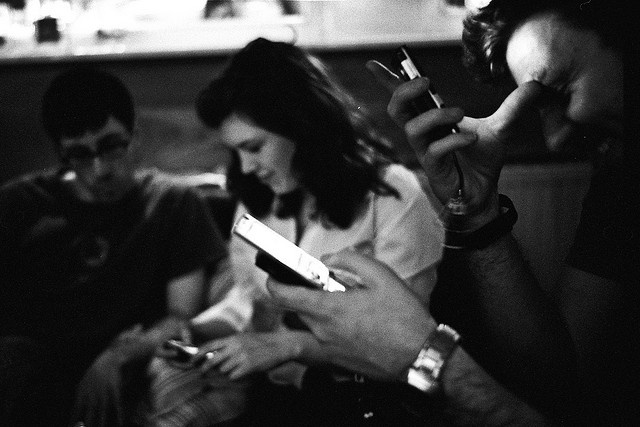Describe the objects in this image and their specific colors. I can see people in black, gray, darkgray, and lightgray tones, people in black, gray, darkgray, and lightgray tones, people in black, gray, darkgray, and lightgray tones, remote in black, white, darkgray, and gray tones, and cell phone in black, white, darkgray, and gray tones in this image. 